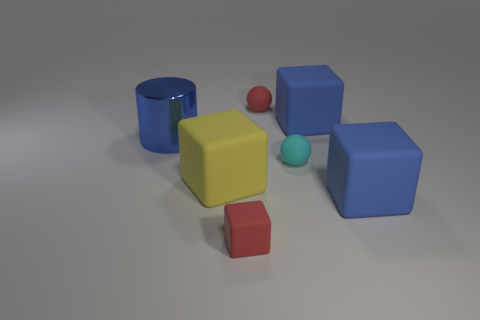Add 2 rubber cubes. How many objects exist? 9 Subtract all blocks. How many objects are left? 3 Add 4 large metallic things. How many large metallic things are left? 5 Add 6 small rubber balls. How many small rubber balls exist? 8 Subtract 1 yellow cubes. How many objects are left? 6 Subtract all spheres. Subtract all cylinders. How many objects are left? 4 